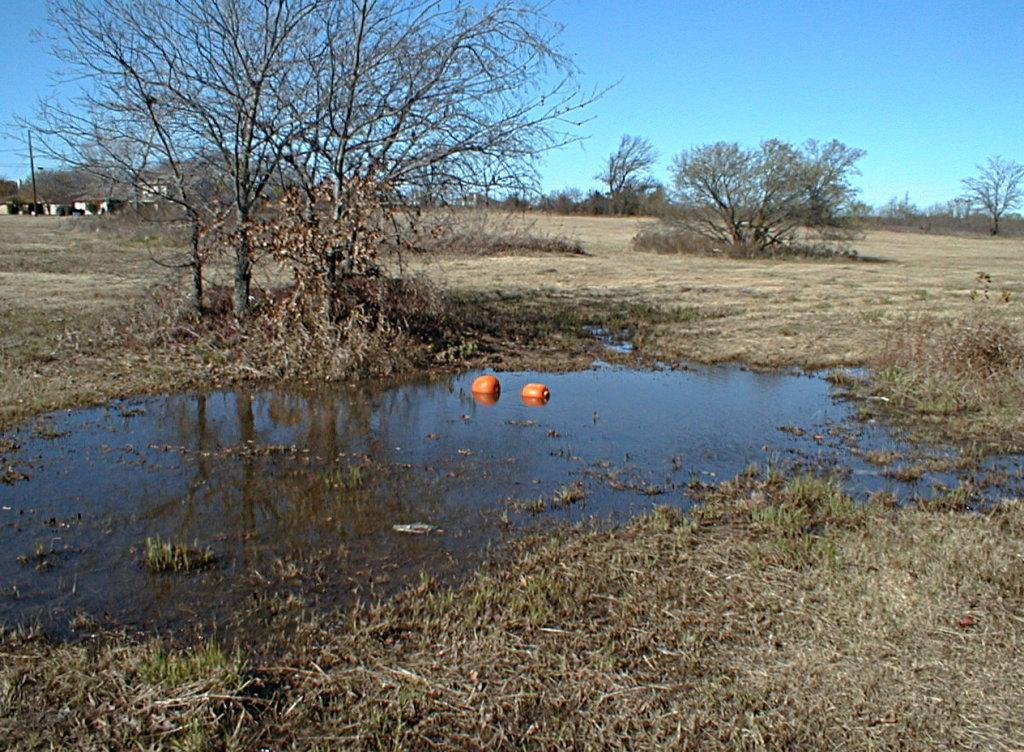What is the main feature of the image? There is a small water surface in the image. What can be observed around the water surface? There are many dry trees around the water surface. What type of vegetation is present in the image? There is dry grass in the image. What type of locket can be seen hanging from one of the dry trees in the image? There is no locket present in the image; it only features a small water surface, dry trees, and dry grass. 